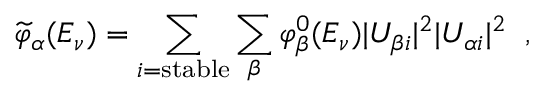<formula> <loc_0><loc_0><loc_500><loc_500>\widetilde { \varphi } _ { \alpha } ( E _ { \nu } ) = \sum _ { i = s t a b l e } \sum _ { \beta } \varphi _ { \beta } ^ { 0 } ( E _ { \nu } ) | U _ { \beta i } | ^ { 2 } | U _ { \alpha i } | ^ { 2 } \, ,</formula> 